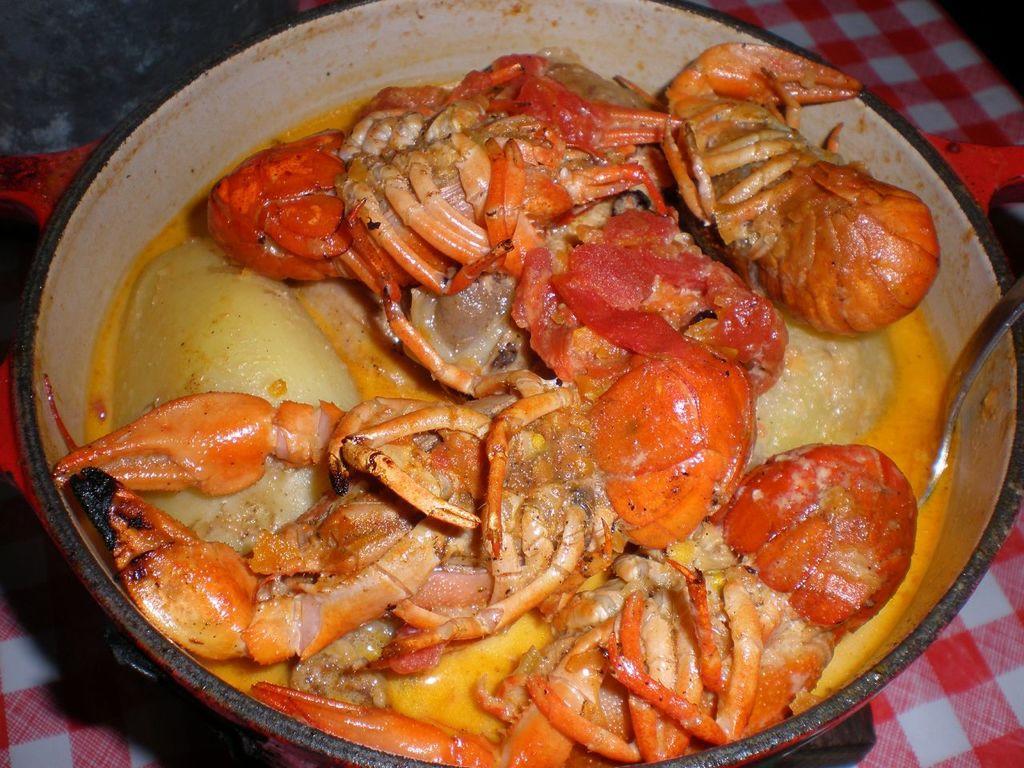How would you summarize this image in a sentence or two? In this image there are crabs and a spoon in a bowl , on the red and white color cloth. 